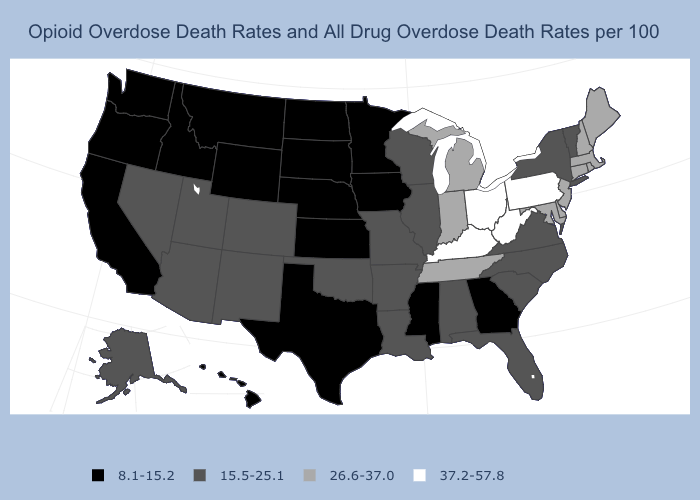Name the states that have a value in the range 8.1-15.2?
Give a very brief answer. California, Georgia, Hawaii, Idaho, Iowa, Kansas, Minnesota, Mississippi, Montana, Nebraska, North Dakota, Oregon, South Dakota, Texas, Washington, Wyoming. Which states have the highest value in the USA?
Write a very short answer. Kentucky, Ohio, Pennsylvania, West Virginia. Which states have the lowest value in the South?
Answer briefly. Georgia, Mississippi, Texas. Name the states that have a value in the range 37.2-57.8?
Short answer required. Kentucky, Ohio, Pennsylvania, West Virginia. Name the states that have a value in the range 15.5-25.1?
Quick response, please. Alabama, Alaska, Arizona, Arkansas, Colorado, Florida, Illinois, Louisiana, Missouri, Nevada, New Mexico, New York, North Carolina, Oklahoma, South Carolina, Utah, Vermont, Virginia, Wisconsin. Does the first symbol in the legend represent the smallest category?
Write a very short answer. Yes. Does Kansas have the lowest value in the USA?
Concise answer only. Yes. What is the value of Utah?
Give a very brief answer. 15.5-25.1. Name the states that have a value in the range 15.5-25.1?
Write a very short answer. Alabama, Alaska, Arizona, Arkansas, Colorado, Florida, Illinois, Louisiana, Missouri, Nevada, New Mexico, New York, North Carolina, Oklahoma, South Carolina, Utah, Vermont, Virginia, Wisconsin. What is the value of West Virginia?
Be succinct. 37.2-57.8. What is the lowest value in the USA?
Give a very brief answer. 8.1-15.2. Name the states that have a value in the range 15.5-25.1?
Short answer required. Alabama, Alaska, Arizona, Arkansas, Colorado, Florida, Illinois, Louisiana, Missouri, Nevada, New Mexico, New York, North Carolina, Oklahoma, South Carolina, Utah, Vermont, Virginia, Wisconsin. What is the value of Arizona?
Answer briefly. 15.5-25.1. Does the map have missing data?
Write a very short answer. No. What is the value of Montana?
Keep it brief. 8.1-15.2. 